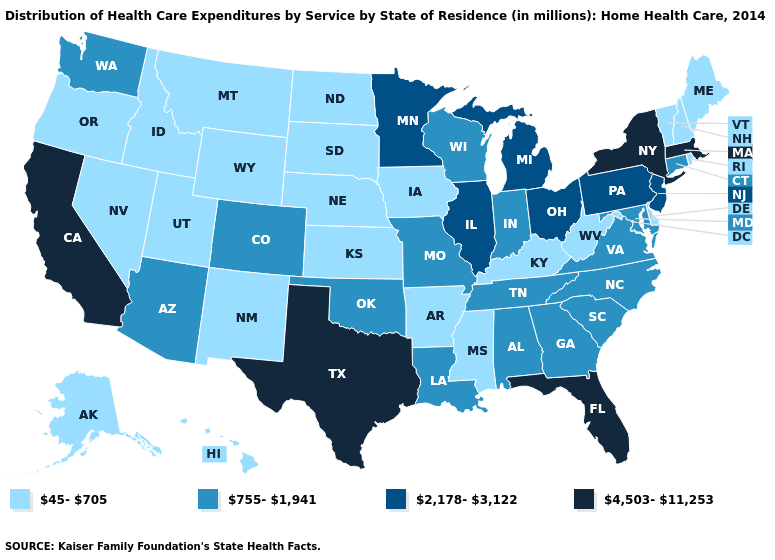Name the states that have a value in the range 45-705?
Concise answer only. Alaska, Arkansas, Delaware, Hawaii, Idaho, Iowa, Kansas, Kentucky, Maine, Mississippi, Montana, Nebraska, Nevada, New Hampshire, New Mexico, North Dakota, Oregon, Rhode Island, South Dakota, Utah, Vermont, West Virginia, Wyoming. Name the states that have a value in the range 4,503-11,253?
Keep it brief. California, Florida, Massachusetts, New York, Texas. Name the states that have a value in the range 2,178-3,122?
Keep it brief. Illinois, Michigan, Minnesota, New Jersey, Ohio, Pennsylvania. Among the states that border Nevada , which have the lowest value?
Write a very short answer. Idaho, Oregon, Utah. Name the states that have a value in the range 755-1,941?
Concise answer only. Alabama, Arizona, Colorado, Connecticut, Georgia, Indiana, Louisiana, Maryland, Missouri, North Carolina, Oklahoma, South Carolina, Tennessee, Virginia, Washington, Wisconsin. What is the value of Minnesota?
Concise answer only. 2,178-3,122. What is the value of Alaska?
Short answer required. 45-705. Does Minnesota have a higher value than California?
Write a very short answer. No. Among the states that border Missouri , does Arkansas have the lowest value?
Write a very short answer. Yes. Among the states that border California , which have the highest value?
Concise answer only. Arizona. What is the highest value in the West ?
Quick response, please. 4,503-11,253. Among the states that border Wisconsin , does Michigan have the highest value?
Quick response, please. Yes. Does Maine have the same value as North Carolina?
Be succinct. No. Does Nebraska have the highest value in the USA?
Quick response, please. No. 